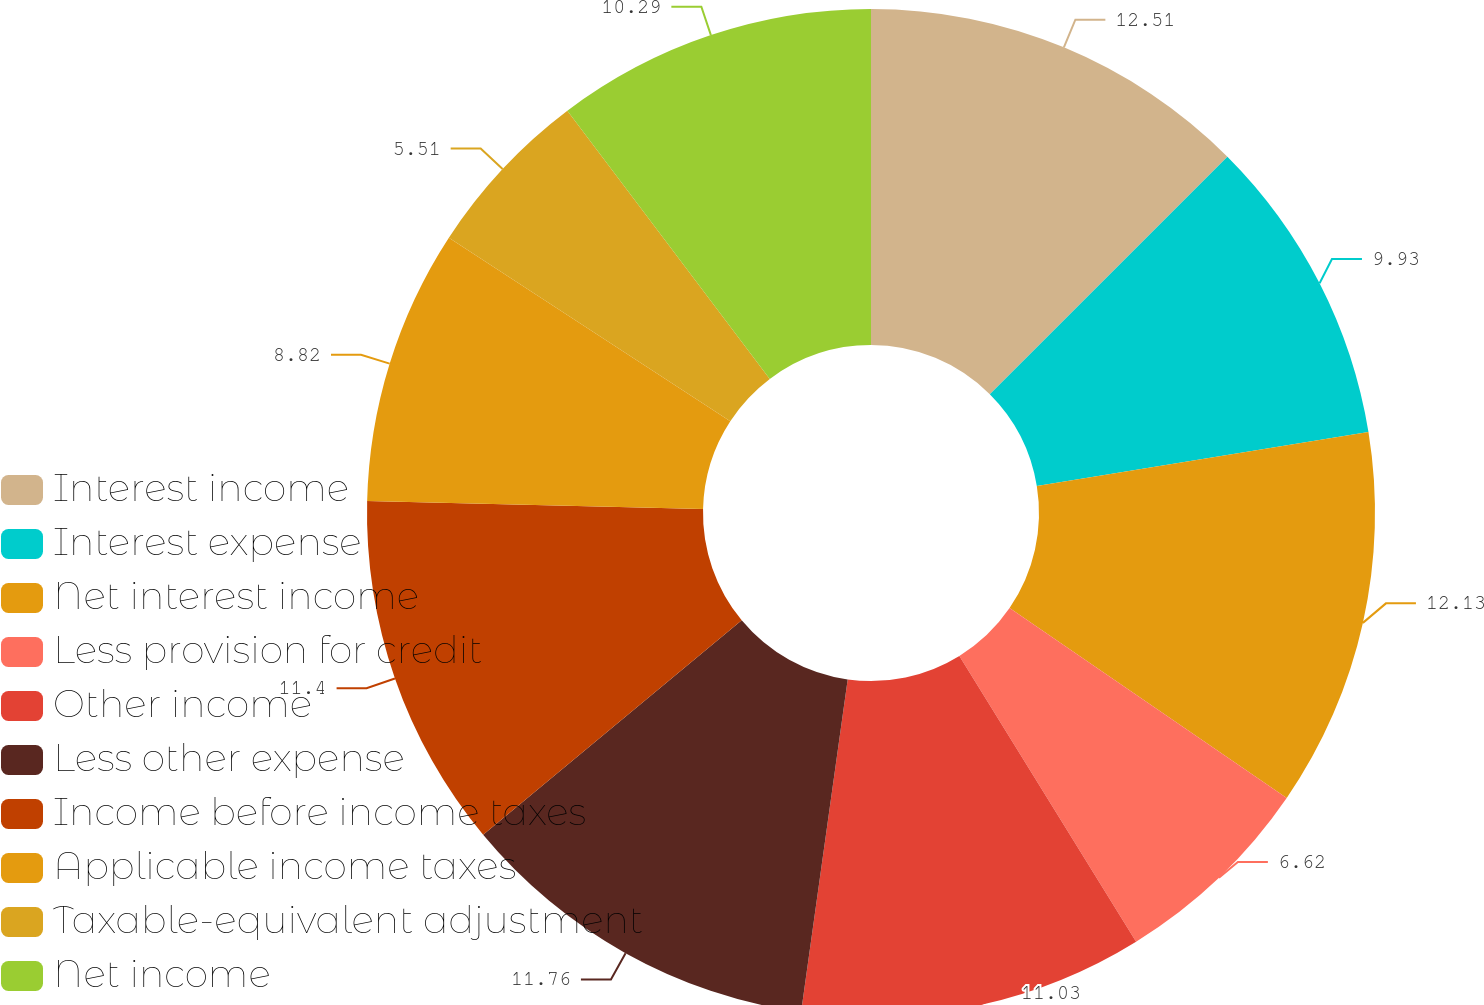Convert chart. <chart><loc_0><loc_0><loc_500><loc_500><pie_chart><fcel>Interest income<fcel>Interest expense<fcel>Net interest income<fcel>Less provision for credit<fcel>Other income<fcel>Less other expense<fcel>Income before income taxes<fcel>Applicable income taxes<fcel>Taxable-equivalent adjustment<fcel>Net income<nl><fcel>12.5%<fcel>9.93%<fcel>12.13%<fcel>6.62%<fcel>11.03%<fcel>11.76%<fcel>11.4%<fcel>8.82%<fcel>5.51%<fcel>10.29%<nl></chart> 